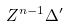Convert formula to latex. <formula><loc_0><loc_0><loc_500><loc_500>Z ^ { n - 1 } \Delta ^ { \prime }</formula> 